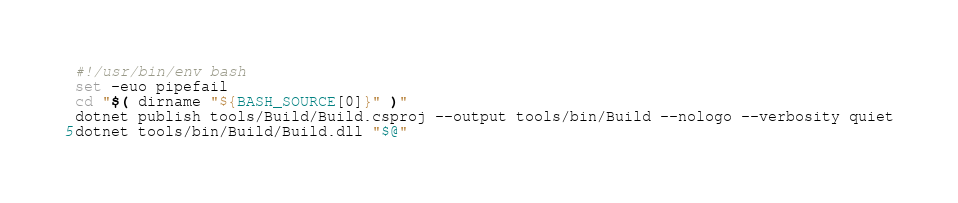<code> <loc_0><loc_0><loc_500><loc_500><_Bash_>#!/usr/bin/env bash
set -euo pipefail
cd "$( dirname "${BASH_SOURCE[0]}" )"
dotnet publish tools/Build/Build.csproj --output tools/bin/Build --nologo --verbosity quiet
dotnet tools/bin/Build/Build.dll "$@"
</code> 